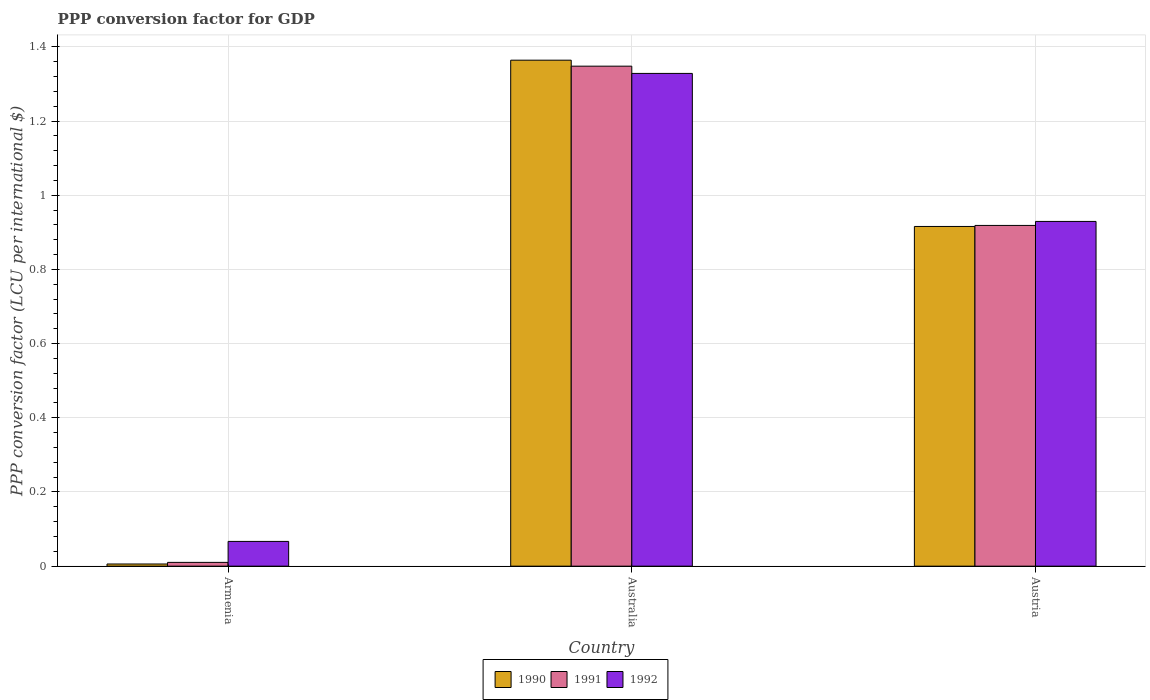How many groups of bars are there?
Provide a succinct answer. 3. Are the number of bars per tick equal to the number of legend labels?
Your answer should be compact. Yes. Are the number of bars on each tick of the X-axis equal?
Your response must be concise. Yes. How many bars are there on the 2nd tick from the right?
Ensure brevity in your answer.  3. What is the label of the 3rd group of bars from the left?
Make the answer very short. Austria. What is the PPP conversion factor for GDP in 1992 in Australia?
Offer a very short reply. 1.33. Across all countries, what is the maximum PPP conversion factor for GDP in 1992?
Ensure brevity in your answer.  1.33. Across all countries, what is the minimum PPP conversion factor for GDP in 1991?
Your response must be concise. 0.01. In which country was the PPP conversion factor for GDP in 1992 minimum?
Provide a succinct answer. Armenia. What is the total PPP conversion factor for GDP in 1991 in the graph?
Provide a succinct answer. 2.28. What is the difference between the PPP conversion factor for GDP in 1991 in Australia and that in Austria?
Give a very brief answer. 0.43. What is the difference between the PPP conversion factor for GDP in 1990 in Armenia and the PPP conversion factor for GDP in 1992 in Australia?
Offer a terse response. -1.32. What is the average PPP conversion factor for GDP in 1990 per country?
Offer a very short reply. 0.76. What is the difference between the PPP conversion factor for GDP of/in 1991 and PPP conversion factor for GDP of/in 1990 in Austria?
Your answer should be very brief. 0. What is the ratio of the PPP conversion factor for GDP in 1991 in Australia to that in Austria?
Offer a very short reply. 1.47. Is the difference between the PPP conversion factor for GDP in 1991 in Australia and Austria greater than the difference between the PPP conversion factor for GDP in 1990 in Australia and Austria?
Offer a terse response. No. What is the difference between the highest and the second highest PPP conversion factor for GDP in 1990?
Your answer should be compact. -0.45. What is the difference between the highest and the lowest PPP conversion factor for GDP in 1990?
Provide a succinct answer. 1.36. In how many countries, is the PPP conversion factor for GDP in 1991 greater than the average PPP conversion factor for GDP in 1991 taken over all countries?
Ensure brevity in your answer.  2. Is the sum of the PPP conversion factor for GDP in 1991 in Armenia and Australia greater than the maximum PPP conversion factor for GDP in 1992 across all countries?
Offer a very short reply. Yes. What is the difference between two consecutive major ticks on the Y-axis?
Your answer should be very brief. 0.2. Does the graph contain any zero values?
Give a very brief answer. No. Does the graph contain grids?
Make the answer very short. Yes. Where does the legend appear in the graph?
Make the answer very short. Bottom center. How are the legend labels stacked?
Your response must be concise. Horizontal. What is the title of the graph?
Your response must be concise. PPP conversion factor for GDP. What is the label or title of the Y-axis?
Offer a terse response. PPP conversion factor (LCU per international $). What is the PPP conversion factor (LCU per international $) in 1990 in Armenia?
Provide a short and direct response. 0.01. What is the PPP conversion factor (LCU per international $) of 1991 in Armenia?
Give a very brief answer. 0.01. What is the PPP conversion factor (LCU per international $) in 1992 in Armenia?
Provide a succinct answer. 0.07. What is the PPP conversion factor (LCU per international $) in 1990 in Australia?
Your response must be concise. 1.36. What is the PPP conversion factor (LCU per international $) in 1991 in Australia?
Offer a terse response. 1.35. What is the PPP conversion factor (LCU per international $) in 1992 in Australia?
Ensure brevity in your answer.  1.33. What is the PPP conversion factor (LCU per international $) in 1990 in Austria?
Your answer should be very brief. 0.92. What is the PPP conversion factor (LCU per international $) in 1991 in Austria?
Give a very brief answer. 0.92. What is the PPP conversion factor (LCU per international $) in 1992 in Austria?
Provide a short and direct response. 0.93. Across all countries, what is the maximum PPP conversion factor (LCU per international $) of 1990?
Your answer should be very brief. 1.36. Across all countries, what is the maximum PPP conversion factor (LCU per international $) of 1991?
Give a very brief answer. 1.35. Across all countries, what is the maximum PPP conversion factor (LCU per international $) in 1992?
Your answer should be compact. 1.33. Across all countries, what is the minimum PPP conversion factor (LCU per international $) of 1990?
Your answer should be very brief. 0.01. Across all countries, what is the minimum PPP conversion factor (LCU per international $) of 1991?
Offer a very short reply. 0.01. Across all countries, what is the minimum PPP conversion factor (LCU per international $) of 1992?
Offer a very short reply. 0.07. What is the total PPP conversion factor (LCU per international $) in 1990 in the graph?
Provide a short and direct response. 2.29. What is the total PPP conversion factor (LCU per international $) in 1991 in the graph?
Your answer should be very brief. 2.28. What is the total PPP conversion factor (LCU per international $) of 1992 in the graph?
Offer a terse response. 2.32. What is the difference between the PPP conversion factor (LCU per international $) in 1990 in Armenia and that in Australia?
Give a very brief answer. -1.36. What is the difference between the PPP conversion factor (LCU per international $) of 1991 in Armenia and that in Australia?
Your answer should be very brief. -1.34. What is the difference between the PPP conversion factor (LCU per international $) of 1992 in Armenia and that in Australia?
Ensure brevity in your answer.  -1.26. What is the difference between the PPP conversion factor (LCU per international $) of 1990 in Armenia and that in Austria?
Your answer should be very brief. -0.91. What is the difference between the PPP conversion factor (LCU per international $) of 1991 in Armenia and that in Austria?
Ensure brevity in your answer.  -0.91. What is the difference between the PPP conversion factor (LCU per international $) of 1992 in Armenia and that in Austria?
Give a very brief answer. -0.86. What is the difference between the PPP conversion factor (LCU per international $) in 1990 in Australia and that in Austria?
Ensure brevity in your answer.  0.45. What is the difference between the PPP conversion factor (LCU per international $) of 1991 in Australia and that in Austria?
Make the answer very short. 0.43. What is the difference between the PPP conversion factor (LCU per international $) in 1992 in Australia and that in Austria?
Provide a succinct answer. 0.4. What is the difference between the PPP conversion factor (LCU per international $) in 1990 in Armenia and the PPP conversion factor (LCU per international $) in 1991 in Australia?
Make the answer very short. -1.34. What is the difference between the PPP conversion factor (LCU per international $) in 1990 in Armenia and the PPP conversion factor (LCU per international $) in 1992 in Australia?
Make the answer very short. -1.32. What is the difference between the PPP conversion factor (LCU per international $) in 1991 in Armenia and the PPP conversion factor (LCU per international $) in 1992 in Australia?
Keep it short and to the point. -1.32. What is the difference between the PPP conversion factor (LCU per international $) in 1990 in Armenia and the PPP conversion factor (LCU per international $) in 1991 in Austria?
Provide a short and direct response. -0.91. What is the difference between the PPP conversion factor (LCU per international $) in 1990 in Armenia and the PPP conversion factor (LCU per international $) in 1992 in Austria?
Ensure brevity in your answer.  -0.92. What is the difference between the PPP conversion factor (LCU per international $) of 1991 in Armenia and the PPP conversion factor (LCU per international $) of 1992 in Austria?
Give a very brief answer. -0.92. What is the difference between the PPP conversion factor (LCU per international $) in 1990 in Australia and the PPP conversion factor (LCU per international $) in 1991 in Austria?
Provide a succinct answer. 0.45. What is the difference between the PPP conversion factor (LCU per international $) in 1990 in Australia and the PPP conversion factor (LCU per international $) in 1992 in Austria?
Offer a very short reply. 0.43. What is the difference between the PPP conversion factor (LCU per international $) in 1991 in Australia and the PPP conversion factor (LCU per international $) in 1992 in Austria?
Offer a very short reply. 0.42. What is the average PPP conversion factor (LCU per international $) of 1990 per country?
Your answer should be compact. 0.76. What is the average PPP conversion factor (LCU per international $) in 1991 per country?
Provide a succinct answer. 0.76. What is the average PPP conversion factor (LCU per international $) of 1992 per country?
Your answer should be very brief. 0.77. What is the difference between the PPP conversion factor (LCU per international $) of 1990 and PPP conversion factor (LCU per international $) of 1991 in Armenia?
Offer a very short reply. -0. What is the difference between the PPP conversion factor (LCU per international $) of 1990 and PPP conversion factor (LCU per international $) of 1992 in Armenia?
Provide a short and direct response. -0.06. What is the difference between the PPP conversion factor (LCU per international $) of 1991 and PPP conversion factor (LCU per international $) of 1992 in Armenia?
Your answer should be compact. -0.06. What is the difference between the PPP conversion factor (LCU per international $) of 1990 and PPP conversion factor (LCU per international $) of 1991 in Australia?
Provide a short and direct response. 0.02. What is the difference between the PPP conversion factor (LCU per international $) in 1990 and PPP conversion factor (LCU per international $) in 1992 in Australia?
Provide a short and direct response. 0.04. What is the difference between the PPP conversion factor (LCU per international $) in 1991 and PPP conversion factor (LCU per international $) in 1992 in Australia?
Ensure brevity in your answer.  0.02. What is the difference between the PPP conversion factor (LCU per international $) of 1990 and PPP conversion factor (LCU per international $) of 1991 in Austria?
Provide a succinct answer. -0. What is the difference between the PPP conversion factor (LCU per international $) in 1990 and PPP conversion factor (LCU per international $) in 1992 in Austria?
Offer a very short reply. -0.01. What is the difference between the PPP conversion factor (LCU per international $) in 1991 and PPP conversion factor (LCU per international $) in 1992 in Austria?
Give a very brief answer. -0.01. What is the ratio of the PPP conversion factor (LCU per international $) of 1990 in Armenia to that in Australia?
Your response must be concise. 0. What is the ratio of the PPP conversion factor (LCU per international $) in 1991 in Armenia to that in Australia?
Make the answer very short. 0.01. What is the ratio of the PPP conversion factor (LCU per international $) in 1992 in Armenia to that in Australia?
Offer a terse response. 0.05. What is the ratio of the PPP conversion factor (LCU per international $) of 1990 in Armenia to that in Austria?
Offer a terse response. 0.01. What is the ratio of the PPP conversion factor (LCU per international $) in 1991 in Armenia to that in Austria?
Your answer should be very brief. 0.01. What is the ratio of the PPP conversion factor (LCU per international $) of 1992 in Armenia to that in Austria?
Offer a terse response. 0.07. What is the ratio of the PPP conversion factor (LCU per international $) of 1990 in Australia to that in Austria?
Your response must be concise. 1.49. What is the ratio of the PPP conversion factor (LCU per international $) in 1991 in Australia to that in Austria?
Your response must be concise. 1.47. What is the ratio of the PPP conversion factor (LCU per international $) in 1992 in Australia to that in Austria?
Your answer should be very brief. 1.43. What is the difference between the highest and the second highest PPP conversion factor (LCU per international $) of 1990?
Offer a terse response. 0.45. What is the difference between the highest and the second highest PPP conversion factor (LCU per international $) in 1991?
Make the answer very short. 0.43. What is the difference between the highest and the second highest PPP conversion factor (LCU per international $) in 1992?
Provide a succinct answer. 0.4. What is the difference between the highest and the lowest PPP conversion factor (LCU per international $) of 1990?
Your answer should be compact. 1.36. What is the difference between the highest and the lowest PPP conversion factor (LCU per international $) of 1991?
Ensure brevity in your answer.  1.34. What is the difference between the highest and the lowest PPP conversion factor (LCU per international $) of 1992?
Provide a short and direct response. 1.26. 